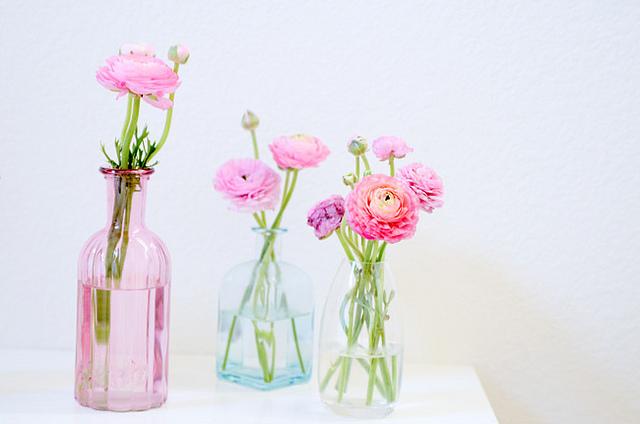How many of the roses are red?
Short answer required. 0. How many different vase designs are there?
Answer briefly. 3. How many flowers are orange?
Quick response, please. 0. Where in the room is this located?
Answer briefly. Living room. Do the roses appear to be freshly-picked?
Be succinct. Yes. What kind of flowers are these?
Quick response, please. Roses. What kind of flower is this?
Answer briefly. Rose. How many different items are visible?
Quick response, please. 3. Are the vases all the same shape?
Answer briefly. No. What color are the main flowers?
Give a very brief answer. Pink. Does these vases have texture?
Keep it brief. No. Are the flowers all the same species?
Concise answer only. Yes. 